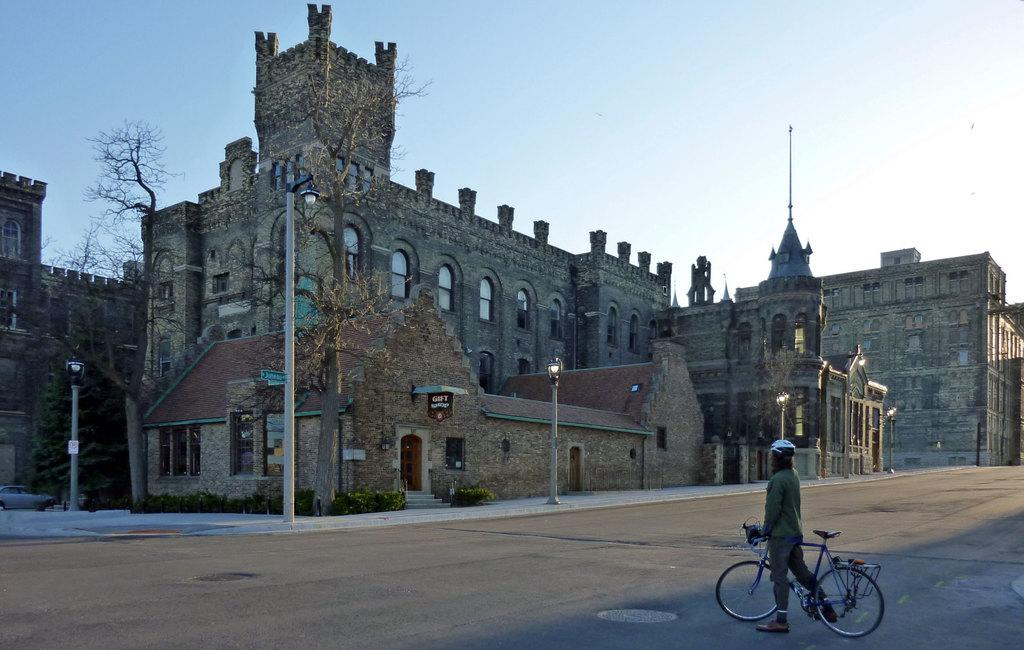What is the person in the image doing? The person is standing on the road surface with a bike. What can be seen in the background behind the person? There are buildings in front of the person. What is located in front of the buildings? There are trees in front of the buildings. What is present in front of the trees? There are lamp posts in front of the trees. What type of soup is being served at the school in the image? There is no school or soup present in the image; it features a person with a bike and various background elements. What degree does the person in the image hold? There is no indication of the person's educational background or degree in the image. 